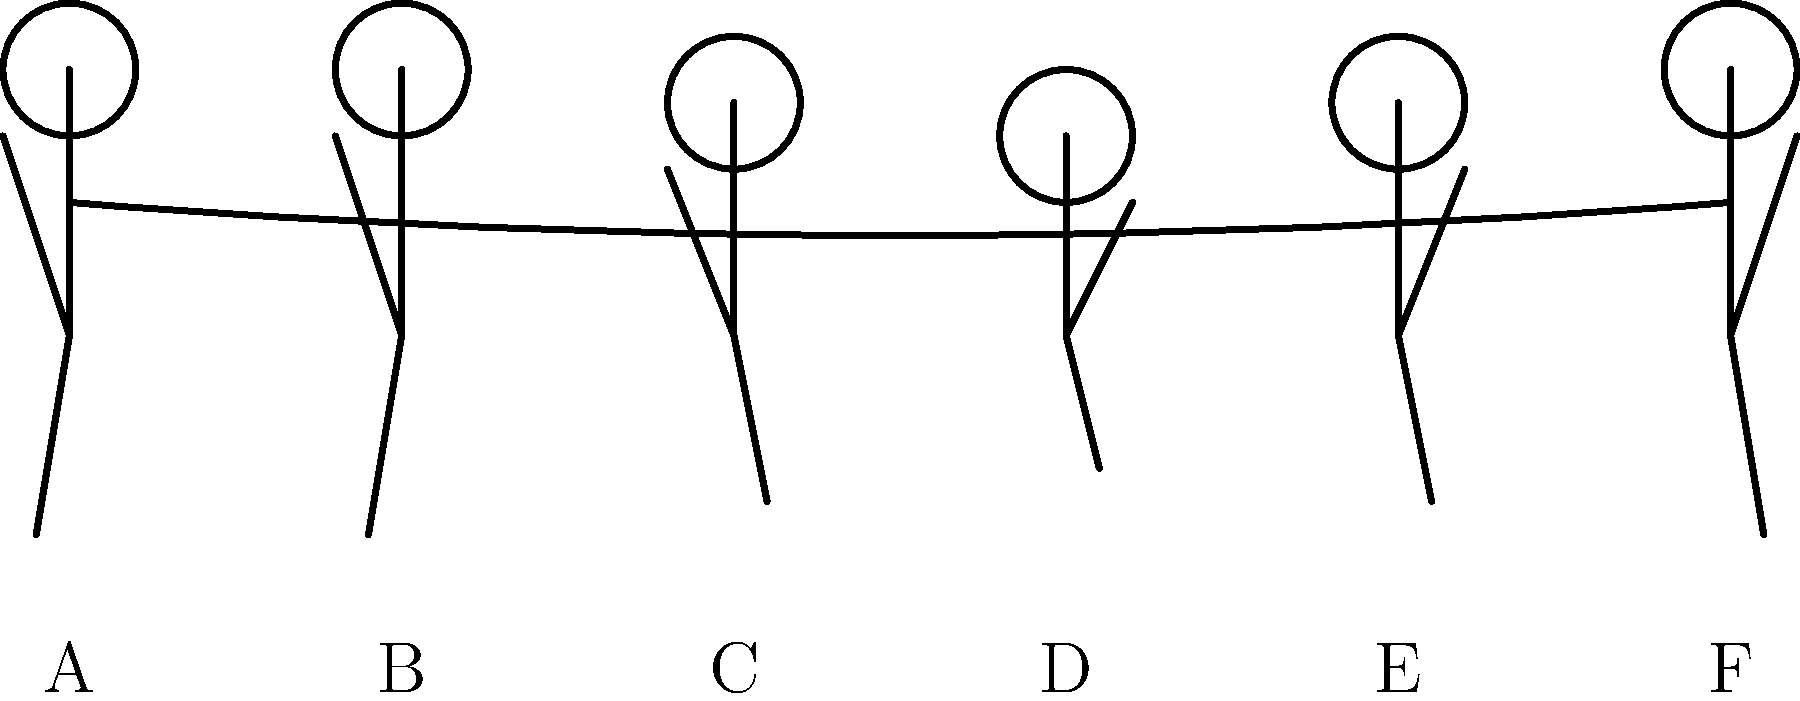In the stick figure sequence diagram of the rowing motion, which phase represents the "catch" position where the oar blade enters the water? To answer this question, we need to analyze the rowing stroke sequence:

1. The rowing stroke is typically divided into four main phases: catch, drive, finish, and recovery.

2. Let's examine each position in the diagram:
   A: The rower is at full extension, legs straight, arms extended forward.
   B: Similar to A, but with a slight lean forward.
   C: The rower begins to bend knees and lean forward more.
   D: Maximum compression, knees fully bent, body leaning forward, arms extended.
   E: Beginning of the drive phase, legs starting to extend.
   F: Similar to A, representing the finish or end of the drive.

3. The "catch" position is where the oar blade enters the water, and the rower is at maximum compression.

4. This position is characterized by:
   - Knees fully bent
   - Body leaning forward
   - Arms fully extended
   - Oar at its farthest point forward

5. Examining the diagram, position D clearly shows these characteristics.

Therefore, the "catch" position in this sequence is represented by position D.
Answer: D 